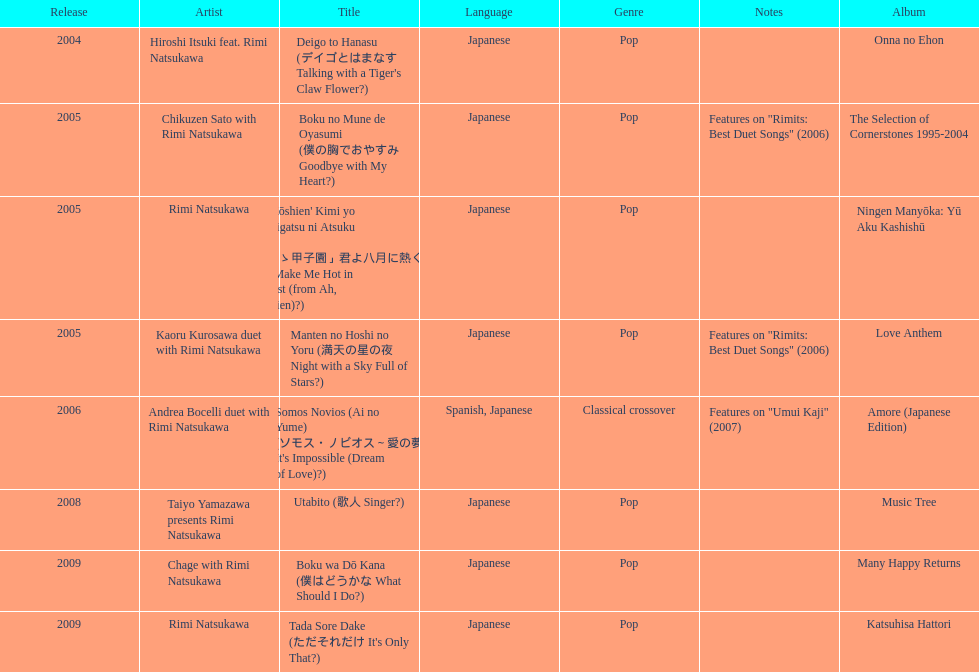What is the last title released? 2009. 